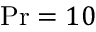Convert formula to latex. <formula><loc_0><loc_0><loc_500><loc_500>P r = 1 0</formula> 